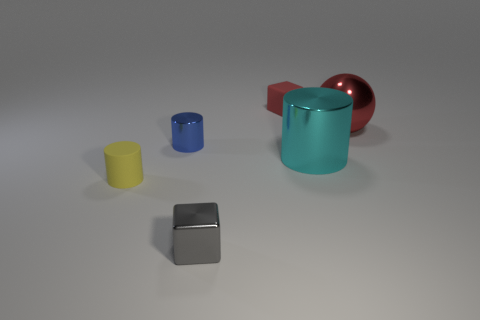Are there more cyan cylinders in front of the small shiny cube than tiny purple matte spheres?
Your answer should be compact. No. How many things are either blocks in front of the large red metal ball or big things in front of the large red metal sphere?
Offer a very short reply. 2. There is a blue cylinder that is the same material as the small gray cube; what is its size?
Provide a short and direct response. Small. There is a rubber thing that is in front of the tiny red block; does it have the same shape as the tiny blue object?
Make the answer very short. Yes. There is a matte block that is the same color as the sphere; what size is it?
Give a very brief answer. Small. How many red things are either tiny metal blocks or big shiny objects?
Your answer should be very brief. 1. How many other objects are the same shape as the gray object?
Offer a very short reply. 1. The tiny object that is both to the right of the blue metal object and in front of the blue shiny cylinder has what shape?
Give a very brief answer. Cube. Are there any spheres to the right of the yellow thing?
Keep it short and to the point. Yes. What is the size of the other object that is the same shape as the small gray object?
Provide a succinct answer. Small. 